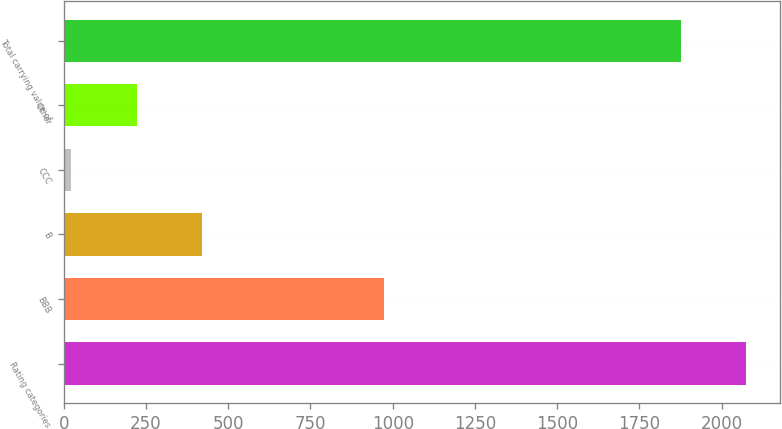Convert chart to OTSL. <chart><loc_0><loc_0><loc_500><loc_500><bar_chart><fcel>Rating categories<fcel>BBB<fcel>B<fcel>CCC<fcel>Other<fcel>Total carrying value of<nl><fcel>2075.2<fcel>973<fcel>421.4<fcel>23<fcel>222.2<fcel>1876<nl></chart> 